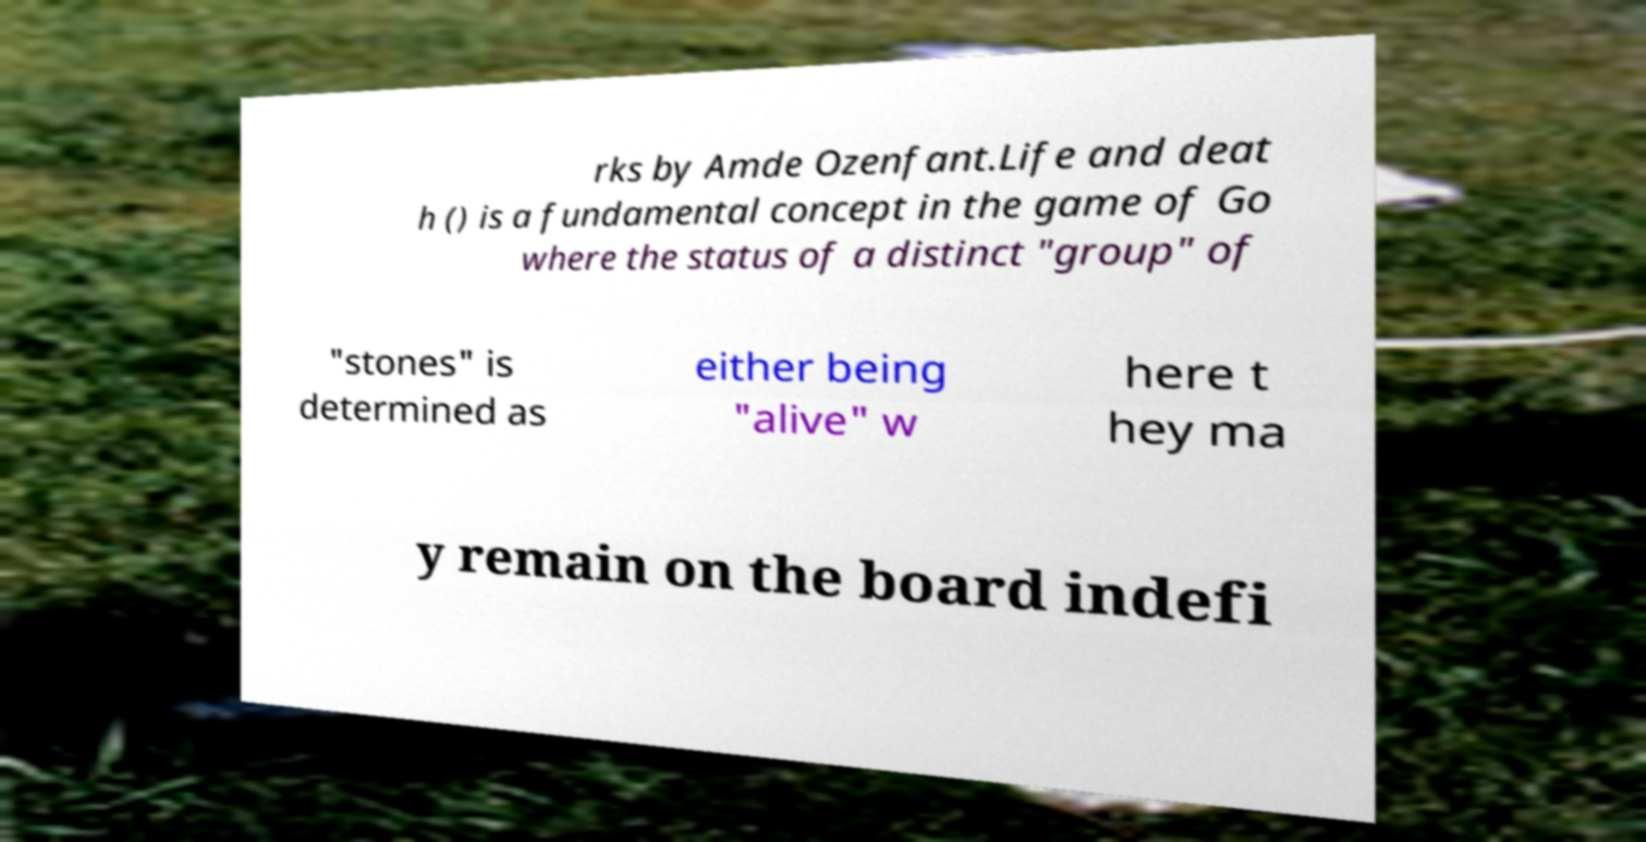Please read and relay the text visible in this image. What does it say? rks by Amde Ozenfant.Life and deat h () is a fundamental concept in the game of Go where the status of a distinct "group" of "stones" is determined as either being "alive" w here t hey ma y remain on the board indefi 